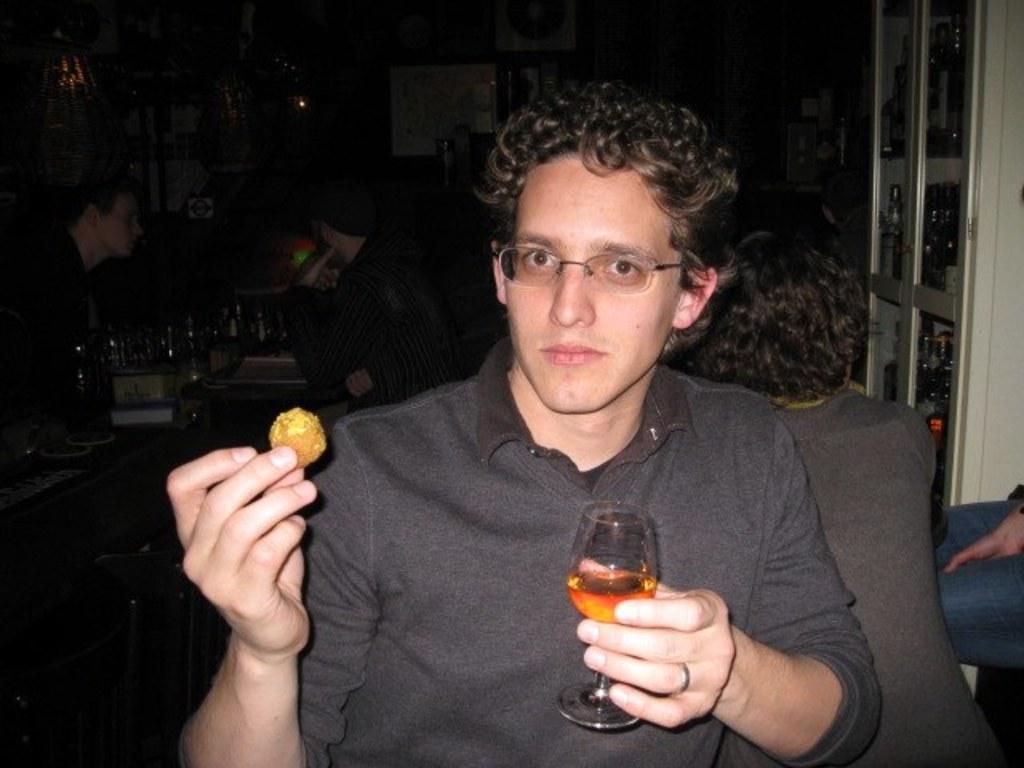Who is present in the image? There is a man in the image. What is the man holding in his hand? The man is holding a meatball and a glass of wine. What type of hair is the man arguing with in the image? There is no argument or hair present in the image; the man is simply holding a meatball and a glass of wine. 